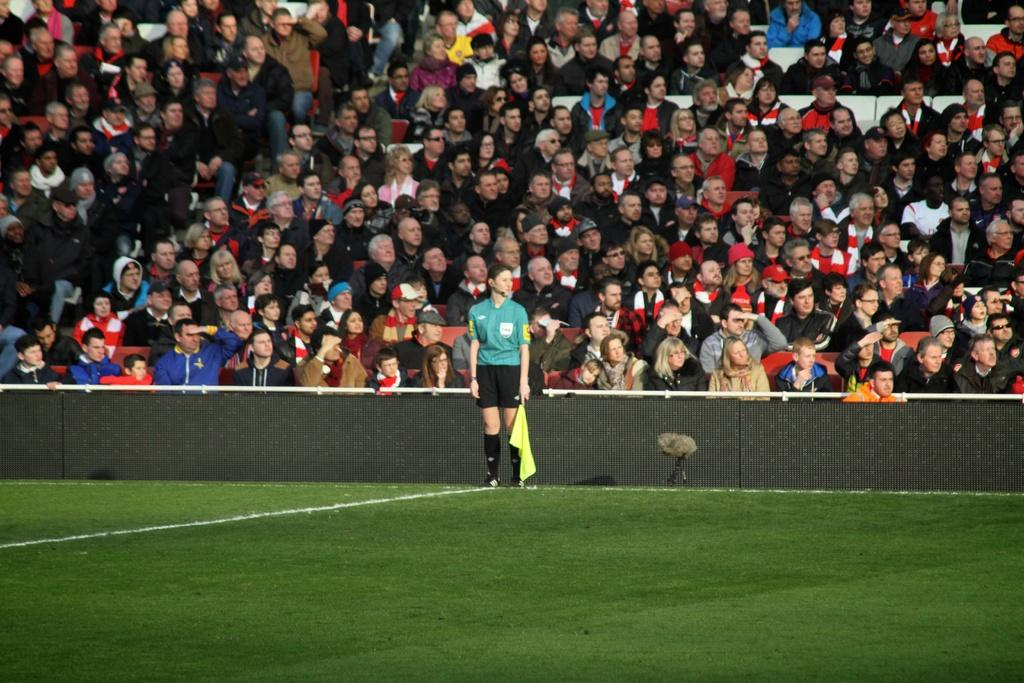What is the woman in the image doing? The woman is standing in the grass. What can be seen in the image besides the woman? There is a fence in the image, and people sitting on chairs in the background. What are the people in the background doing? The people are sitting on chairs and watching something. What type of string is being used for the discovery in the image? There is no mention of a discovery or string in the image; it features a woman standing in the grass, a fence, and people sitting on chairs in the background. 